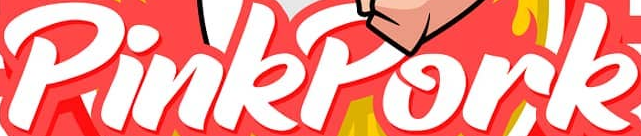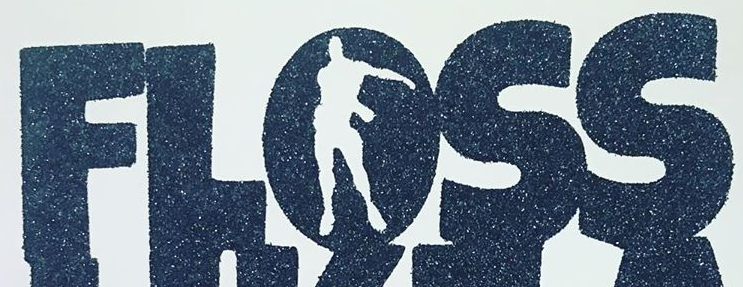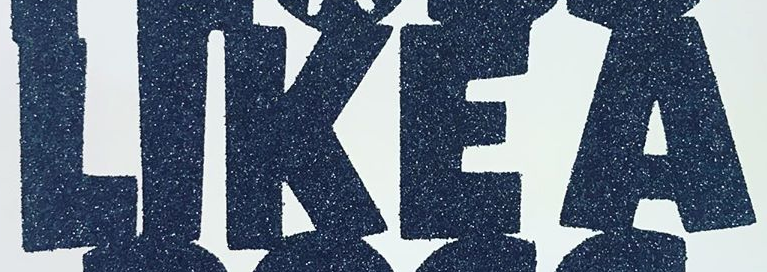What words can you see in these images in sequence, separated by a semicolon? PinkPork; FLOSS; LIKEA 